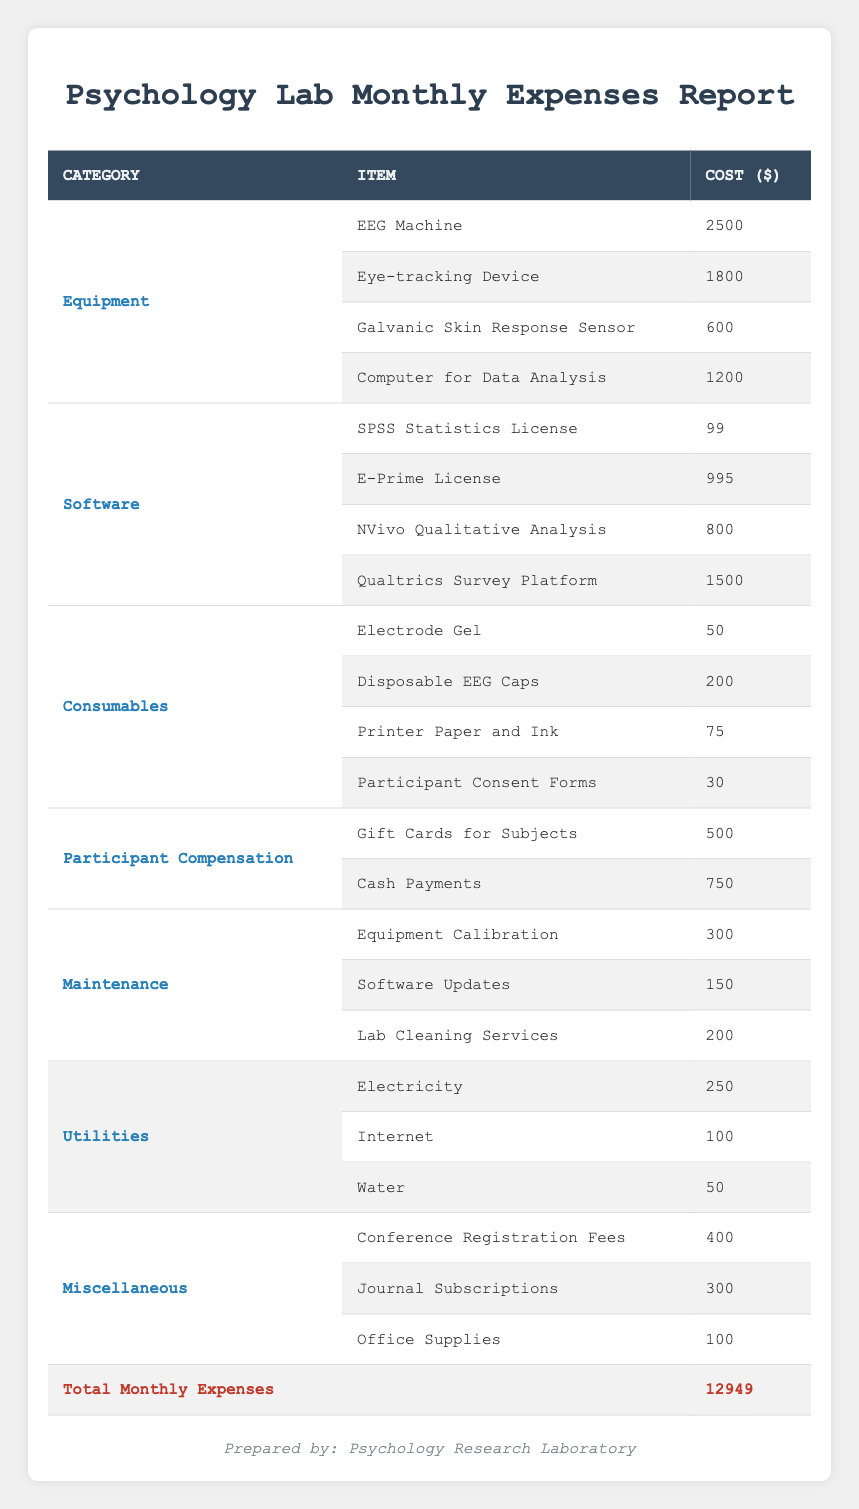What is the total cost of equipment? The equipment category includes four items: EEG Machine for 2500, Eye-tracking Device for 1800, Galvanic Skin Response Sensor for 600, and Computer for Data Analysis for 1200. Summing these amounts gives us 2500 + 1800 + 600 + 1200 = 5100.
Answer: 5100 How much is spent on software licenses? The software category consists of four items: SPSS Statistics License for 99, E-Prime License for 995, NVivo Qualitative Analysis for 800, and Qualtrics Survey Platform for 1500. Adding these costs totals 99 + 995 + 800 + 1500 = 3394.
Answer: 3394 Are the total monthly expenses greater than 12000? The total monthly expenses reported are 12949. Since 12949 is greater than 12000, the statement is true.
Answer: Yes What is the combined cost of utilities? The utilities category includes three items: Electricity for 250, Internet for 100, and Water for 50. Adding these costs gives us 250 + 100 + 50 = 400.
Answer: 400 Is the cost of participant compensation more than the cost of maintenance? The participant compensation costs (Gift Cards for Subjects for 500 and Cash Payments for 750) total 500 + 750 = 1250. The maintenance costs (Equipment Calibration for 300, Software Updates for 150, and Lab Cleaning Services for 200) total 300 + 150 + 200 = 650. Since 1250 is greater than 650, this statement is true.
Answer: Yes What percentage of the total expenses is spent on consumables? The consumables cost includes Electrode Gel for 50, Disposable EEG Caps for 200, Printer Paper and Ink for 75, and Participant Consent Forms for 30, totaling 50 + 200 + 75 + 30 = 355. To find the percentage, we divide the consumables cost by total expenses: (355 / 12949) * 100 ≈ 2.74%.
Answer: Approximately 2.74% Which category has the highest total expense? By analyzing the categories: Equipment totals 5100, Software totals 3394, Consumables total 355, Participant Compensation totals 1250, Maintenance totals 650, Utilities total 400, and Miscellaneous totals 800 (Conference Registration Fees 400 + Journal Subscriptions 300 + Office Supplies 100). The highest total is from Equipment at 5100.
Answer: Equipment What is the average cost of consumable items? The consumables category contains four items costing 50, 200, 75, and 30. First, we sum these values: 50 + 200 + 75 + 30 = 355. Then we calculate the average by dividing the total by the number of items: 355 / 4 = 88.75.
Answer: 88.75 How much do utilities account for compared to the total monthly expenses? Utilities costs total 400 (from Electricity, Internet, and Water). To find the account percentage, we calculate (400 / 12949) * 100 ≈ 3.09%.
Answer: Approximately 3.09% 